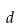<formula> <loc_0><loc_0><loc_500><loc_500>d</formula> 